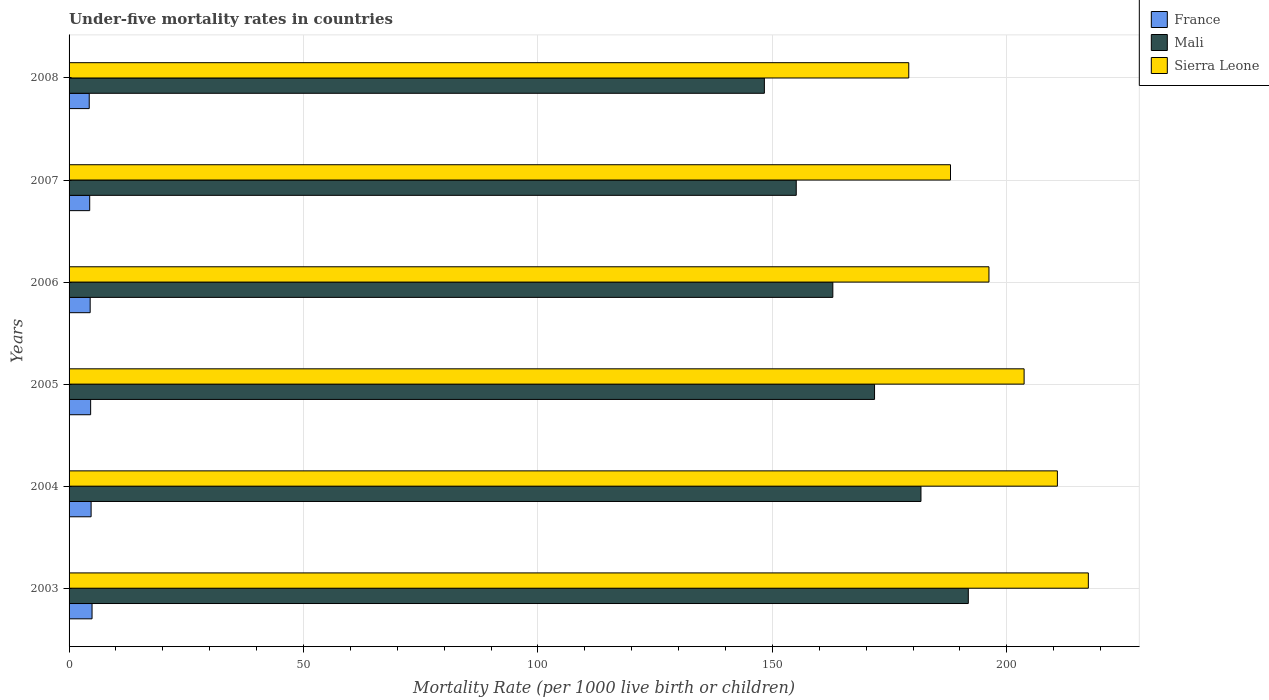How many different coloured bars are there?
Offer a terse response. 3. How many groups of bars are there?
Offer a terse response. 6. Are the number of bars per tick equal to the number of legend labels?
Your answer should be compact. Yes. Are the number of bars on each tick of the Y-axis equal?
Ensure brevity in your answer.  Yes. How many bars are there on the 4th tick from the bottom?
Offer a very short reply. 3. What is the label of the 6th group of bars from the top?
Provide a succinct answer. 2003. Across all years, what is the maximum under-five mortality rate in France?
Offer a terse response. 4.9. Across all years, what is the minimum under-five mortality rate in Sierra Leone?
Your response must be concise. 179.1. In which year was the under-five mortality rate in Sierra Leone maximum?
Your answer should be very brief. 2003. In which year was the under-five mortality rate in France minimum?
Provide a succinct answer. 2008. What is the total under-five mortality rate in Sierra Leone in the graph?
Ensure brevity in your answer.  1195.2. What is the difference between the under-five mortality rate in France in 2006 and that in 2008?
Your answer should be very brief. 0.2. What is the difference between the under-five mortality rate in Mali in 2008 and the under-five mortality rate in France in 2003?
Keep it short and to the point. 143.4. What is the average under-five mortality rate in Mali per year?
Your response must be concise. 168.6. In the year 2007, what is the difference between the under-five mortality rate in Sierra Leone and under-five mortality rate in France?
Ensure brevity in your answer.  183.6. In how many years, is the under-five mortality rate in France greater than 80 ?
Your answer should be compact. 0. What is the ratio of the under-five mortality rate in Mali in 2003 to that in 2005?
Your answer should be very brief. 1.12. Is the under-five mortality rate in Mali in 2004 less than that in 2008?
Your answer should be very brief. No. Is the difference between the under-five mortality rate in Sierra Leone in 2004 and 2007 greater than the difference between the under-five mortality rate in France in 2004 and 2007?
Your response must be concise. Yes. What is the difference between the highest and the second highest under-five mortality rate in France?
Keep it short and to the point. 0.2. What is the difference between the highest and the lowest under-five mortality rate in France?
Make the answer very short. 0.6. Is the sum of the under-five mortality rate in France in 2003 and 2005 greater than the maximum under-five mortality rate in Sierra Leone across all years?
Ensure brevity in your answer.  No. What does the 2nd bar from the top in 2003 represents?
Provide a succinct answer. Mali. What does the 2nd bar from the bottom in 2004 represents?
Keep it short and to the point. Mali. How many bars are there?
Keep it short and to the point. 18. How many years are there in the graph?
Offer a terse response. 6. What is the difference between two consecutive major ticks on the X-axis?
Keep it short and to the point. 50. Are the values on the major ticks of X-axis written in scientific E-notation?
Offer a terse response. No. How are the legend labels stacked?
Make the answer very short. Vertical. What is the title of the graph?
Ensure brevity in your answer.  Under-five mortality rates in countries. Does "Luxembourg" appear as one of the legend labels in the graph?
Give a very brief answer. No. What is the label or title of the X-axis?
Ensure brevity in your answer.  Mortality Rate (per 1000 live birth or children). What is the label or title of the Y-axis?
Offer a terse response. Years. What is the Mortality Rate (per 1000 live birth or children) of Mali in 2003?
Provide a short and direct response. 191.8. What is the Mortality Rate (per 1000 live birth or children) in Sierra Leone in 2003?
Provide a short and direct response. 217.4. What is the Mortality Rate (per 1000 live birth or children) of France in 2004?
Provide a succinct answer. 4.7. What is the Mortality Rate (per 1000 live birth or children) in Mali in 2004?
Provide a succinct answer. 181.7. What is the Mortality Rate (per 1000 live birth or children) of Sierra Leone in 2004?
Offer a terse response. 210.8. What is the Mortality Rate (per 1000 live birth or children) in Mali in 2005?
Your answer should be compact. 171.8. What is the Mortality Rate (per 1000 live birth or children) of Sierra Leone in 2005?
Your answer should be compact. 203.7. What is the Mortality Rate (per 1000 live birth or children) in France in 2006?
Your answer should be very brief. 4.5. What is the Mortality Rate (per 1000 live birth or children) in Mali in 2006?
Ensure brevity in your answer.  162.9. What is the Mortality Rate (per 1000 live birth or children) in Sierra Leone in 2006?
Offer a terse response. 196.2. What is the Mortality Rate (per 1000 live birth or children) in France in 2007?
Provide a short and direct response. 4.4. What is the Mortality Rate (per 1000 live birth or children) in Mali in 2007?
Make the answer very short. 155.1. What is the Mortality Rate (per 1000 live birth or children) of Sierra Leone in 2007?
Provide a succinct answer. 188. What is the Mortality Rate (per 1000 live birth or children) in Mali in 2008?
Your response must be concise. 148.3. What is the Mortality Rate (per 1000 live birth or children) in Sierra Leone in 2008?
Ensure brevity in your answer.  179.1. Across all years, what is the maximum Mortality Rate (per 1000 live birth or children) in France?
Give a very brief answer. 4.9. Across all years, what is the maximum Mortality Rate (per 1000 live birth or children) in Mali?
Your answer should be very brief. 191.8. Across all years, what is the maximum Mortality Rate (per 1000 live birth or children) in Sierra Leone?
Give a very brief answer. 217.4. Across all years, what is the minimum Mortality Rate (per 1000 live birth or children) in Mali?
Offer a terse response. 148.3. Across all years, what is the minimum Mortality Rate (per 1000 live birth or children) of Sierra Leone?
Make the answer very short. 179.1. What is the total Mortality Rate (per 1000 live birth or children) of France in the graph?
Provide a short and direct response. 27.4. What is the total Mortality Rate (per 1000 live birth or children) of Mali in the graph?
Provide a short and direct response. 1011.6. What is the total Mortality Rate (per 1000 live birth or children) of Sierra Leone in the graph?
Provide a succinct answer. 1195.2. What is the difference between the Mortality Rate (per 1000 live birth or children) of France in 2003 and that in 2004?
Keep it short and to the point. 0.2. What is the difference between the Mortality Rate (per 1000 live birth or children) in Mali in 2003 and that in 2004?
Offer a terse response. 10.1. What is the difference between the Mortality Rate (per 1000 live birth or children) in Sierra Leone in 2003 and that in 2004?
Your answer should be compact. 6.6. What is the difference between the Mortality Rate (per 1000 live birth or children) of Mali in 2003 and that in 2005?
Your response must be concise. 20. What is the difference between the Mortality Rate (per 1000 live birth or children) in Sierra Leone in 2003 and that in 2005?
Ensure brevity in your answer.  13.7. What is the difference between the Mortality Rate (per 1000 live birth or children) of Mali in 2003 and that in 2006?
Your response must be concise. 28.9. What is the difference between the Mortality Rate (per 1000 live birth or children) in Sierra Leone in 2003 and that in 2006?
Offer a very short reply. 21.2. What is the difference between the Mortality Rate (per 1000 live birth or children) of Mali in 2003 and that in 2007?
Offer a very short reply. 36.7. What is the difference between the Mortality Rate (per 1000 live birth or children) in Sierra Leone in 2003 and that in 2007?
Provide a succinct answer. 29.4. What is the difference between the Mortality Rate (per 1000 live birth or children) in Mali in 2003 and that in 2008?
Provide a succinct answer. 43.5. What is the difference between the Mortality Rate (per 1000 live birth or children) of Sierra Leone in 2003 and that in 2008?
Keep it short and to the point. 38.3. What is the difference between the Mortality Rate (per 1000 live birth or children) of France in 2004 and that in 2005?
Offer a very short reply. 0.1. What is the difference between the Mortality Rate (per 1000 live birth or children) of Sierra Leone in 2004 and that in 2005?
Give a very brief answer. 7.1. What is the difference between the Mortality Rate (per 1000 live birth or children) of France in 2004 and that in 2006?
Offer a very short reply. 0.2. What is the difference between the Mortality Rate (per 1000 live birth or children) in Mali in 2004 and that in 2006?
Your answer should be very brief. 18.8. What is the difference between the Mortality Rate (per 1000 live birth or children) of Mali in 2004 and that in 2007?
Your answer should be compact. 26.6. What is the difference between the Mortality Rate (per 1000 live birth or children) in Sierra Leone in 2004 and that in 2007?
Your answer should be very brief. 22.8. What is the difference between the Mortality Rate (per 1000 live birth or children) of Mali in 2004 and that in 2008?
Give a very brief answer. 33.4. What is the difference between the Mortality Rate (per 1000 live birth or children) of Sierra Leone in 2004 and that in 2008?
Make the answer very short. 31.7. What is the difference between the Mortality Rate (per 1000 live birth or children) in France in 2005 and that in 2006?
Provide a succinct answer. 0.1. What is the difference between the Mortality Rate (per 1000 live birth or children) of Mali in 2005 and that in 2006?
Your answer should be very brief. 8.9. What is the difference between the Mortality Rate (per 1000 live birth or children) of Sierra Leone in 2005 and that in 2006?
Provide a short and direct response. 7.5. What is the difference between the Mortality Rate (per 1000 live birth or children) in Mali in 2005 and that in 2007?
Your answer should be very brief. 16.7. What is the difference between the Mortality Rate (per 1000 live birth or children) of Sierra Leone in 2005 and that in 2007?
Offer a terse response. 15.7. What is the difference between the Mortality Rate (per 1000 live birth or children) of Mali in 2005 and that in 2008?
Provide a succinct answer. 23.5. What is the difference between the Mortality Rate (per 1000 live birth or children) in Sierra Leone in 2005 and that in 2008?
Your response must be concise. 24.6. What is the difference between the Mortality Rate (per 1000 live birth or children) of Mali in 2006 and that in 2007?
Make the answer very short. 7.8. What is the difference between the Mortality Rate (per 1000 live birth or children) of Mali in 2006 and that in 2008?
Your answer should be compact. 14.6. What is the difference between the Mortality Rate (per 1000 live birth or children) in Sierra Leone in 2006 and that in 2008?
Offer a very short reply. 17.1. What is the difference between the Mortality Rate (per 1000 live birth or children) of Mali in 2007 and that in 2008?
Provide a succinct answer. 6.8. What is the difference between the Mortality Rate (per 1000 live birth or children) in Sierra Leone in 2007 and that in 2008?
Your answer should be compact. 8.9. What is the difference between the Mortality Rate (per 1000 live birth or children) of France in 2003 and the Mortality Rate (per 1000 live birth or children) of Mali in 2004?
Give a very brief answer. -176.8. What is the difference between the Mortality Rate (per 1000 live birth or children) of France in 2003 and the Mortality Rate (per 1000 live birth or children) of Sierra Leone in 2004?
Provide a short and direct response. -205.9. What is the difference between the Mortality Rate (per 1000 live birth or children) of Mali in 2003 and the Mortality Rate (per 1000 live birth or children) of Sierra Leone in 2004?
Keep it short and to the point. -19. What is the difference between the Mortality Rate (per 1000 live birth or children) of France in 2003 and the Mortality Rate (per 1000 live birth or children) of Mali in 2005?
Offer a terse response. -166.9. What is the difference between the Mortality Rate (per 1000 live birth or children) of France in 2003 and the Mortality Rate (per 1000 live birth or children) of Sierra Leone in 2005?
Offer a terse response. -198.8. What is the difference between the Mortality Rate (per 1000 live birth or children) of France in 2003 and the Mortality Rate (per 1000 live birth or children) of Mali in 2006?
Provide a short and direct response. -158. What is the difference between the Mortality Rate (per 1000 live birth or children) of France in 2003 and the Mortality Rate (per 1000 live birth or children) of Sierra Leone in 2006?
Your answer should be very brief. -191.3. What is the difference between the Mortality Rate (per 1000 live birth or children) in Mali in 2003 and the Mortality Rate (per 1000 live birth or children) in Sierra Leone in 2006?
Provide a succinct answer. -4.4. What is the difference between the Mortality Rate (per 1000 live birth or children) of France in 2003 and the Mortality Rate (per 1000 live birth or children) of Mali in 2007?
Provide a short and direct response. -150.2. What is the difference between the Mortality Rate (per 1000 live birth or children) of France in 2003 and the Mortality Rate (per 1000 live birth or children) of Sierra Leone in 2007?
Offer a terse response. -183.1. What is the difference between the Mortality Rate (per 1000 live birth or children) of Mali in 2003 and the Mortality Rate (per 1000 live birth or children) of Sierra Leone in 2007?
Your response must be concise. 3.8. What is the difference between the Mortality Rate (per 1000 live birth or children) of France in 2003 and the Mortality Rate (per 1000 live birth or children) of Mali in 2008?
Give a very brief answer. -143.4. What is the difference between the Mortality Rate (per 1000 live birth or children) of France in 2003 and the Mortality Rate (per 1000 live birth or children) of Sierra Leone in 2008?
Provide a succinct answer. -174.2. What is the difference between the Mortality Rate (per 1000 live birth or children) in France in 2004 and the Mortality Rate (per 1000 live birth or children) in Mali in 2005?
Your answer should be compact. -167.1. What is the difference between the Mortality Rate (per 1000 live birth or children) of France in 2004 and the Mortality Rate (per 1000 live birth or children) of Sierra Leone in 2005?
Provide a short and direct response. -199. What is the difference between the Mortality Rate (per 1000 live birth or children) of France in 2004 and the Mortality Rate (per 1000 live birth or children) of Mali in 2006?
Your answer should be very brief. -158.2. What is the difference between the Mortality Rate (per 1000 live birth or children) of France in 2004 and the Mortality Rate (per 1000 live birth or children) of Sierra Leone in 2006?
Your answer should be compact. -191.5. What is the difference between the Mortality Rate (per 1000 live birth or children) in Mali in 2004 and the Mortality Rate (per 1000 live birth or children) in Sierra Leone in 2006?
Provide a short and direct response. -14.5. What is the difference between the Mortality Rate (per 1000 live birth or children) of France in 2004 and the Mortality Rate (per 1000 live birth or children) of Mali in 2007?
Offer a very short reply. -150.4. What is the difference between the Mortality Rate (per 1000 live birth or children) in France in 2004 and the Mortality Rate (per 1000 live birth or children) in Sierra Leone in 2007?
Offer a very short reply. -183.3. What is the difference between the Mortality Rate (per 1000 live birth or children) of Mali in 2004 and the Mortality Rate (per 1000 live birth or children) of Sierra Leone in 2007?
Keep it short and to the point. -6.3. What is the difference between the Mortality Rate (per 1000 live birth or children) of France in 2004 and the Mortality Rate (per 1000 live birth or children) of Mali in 2008?
Provide a short and direct response. -143.6. What is the difference between the Mortality Rate (per 1000 live birth or children) in France in 2004 and the Mortality Rate (per 1000 live birth or children) in Sierra Leone in 2008?
Offer a very short reply. -174.4. What is the difference between the Mortality Rate (per 1000 live birth or children) in Mali in 2004 and the Mortality Rate (per 1000 live birth or children) in Sierra Leone in 2008?
Offer a very short reply. 2.6. What is the difference between the Mortality Rate (per 1000 live birth or children) in France in 2005 and the Mortality Rate (per 1000 live birth or children) in Mali in 2006?
Your answer should be compact. -158.3. What is the difference between the Mortality Rate (per 1000 live birth or children) in France in 2005 and the Mortality Rate (per 1000 live birth or children) in Sierra Leone in 2006?
Your response must be concise. -191.6. What is the difference between the Mortality Rate (per 1000 live birth or children) of Mali in 2005 and the Mortality Rate (per 1000 live birth or children) of Sierra Leone in 2006?
Provide a short and direct response. -24.4. What is the difference between the Mortality Rate (per 1000 live birth or children) in France in 2005 and the Mortality Rate (per 1000 live birth or children) in Mali in 2007?
Give a very brief answer. -150.5. What is the difference between the Mortality Rate (per 1000 live birth or children) in France in 2005 and the Mortality Rate (per 1000 live birth or children) in Sierra Leone in 2007?
Your answer should be very brief. -183.4. What is the difference between the Mortality Rate (per 1000 live birth or children) in Mali in 2005 and the Mortality Rate (per 1000 live birth or children) in Sierra Leone in 2007?
Your answer should be very brief. -16.2. What is the difference between the Mortality Rate (per 1000 live birth or children) in France in 2005 and the Mortality Rate (per 1000 live birth or children) in Mali in 2008?
Keep it short and to the point. -143.7. What is the difference between the Mortality Rate (per 1000 live birth or children) of France in 2005 and the Mortality Rate (per 1000 live birth or children) of Sierra Leone in 2008?
Your response must be concise. -174.5. What is the difference between the Mortality Rate (per 1000 live birth or children) in Mali in 2005 and the Mortality Rate (per 1000 live birth or children) in Sierra Leone in 2008?
Offer a terse response. -7.3. What is the difference between the Mortality Rate (per 1000 live birth or children) in France in 2006 and the Mortality Rate (per 1000 live birth or children) in Mali in 2007?
Your answer should be very brief. -150.6. What is the difference between the Mortality Rate (per 1000 live birth or children) in France in 2006 and the Mortality Rate (per 1000 live birth or children) in Sierra Leone in 2007?
Provide a short and direct response. -183.5. What is the difference between the Mortality Rate (per 1000 live birth or children) of Mali in 2006 and the Mortality Rate (per 1000 live birth or children) of Sierra Leone in 2007?
Your answer should be very brief. -25.1. What is the difference between the Mortality Rate (per 1000 live birth or children) in France in 2006 and the Mortality Rate (per 1000 live birth or children) in Mali in 2008?
Your answer should be very brief. -143.8. What is the difference between the Mortality Rate (per 1000 live birth or children) of France in 2006 and the Mortality Rate (per 1000 live birth or children) of Sierra Leone in 2008?
Offer a terse response. -174.6. What is the difference between the Mortality Rate (per 1000 live birth or children) in Mali in 2006 and the Mortality Rate (per 1000 live birth or children) in Sierra Leone in 2008?
Offer a very short reply. -16.2. What is the difference between the Mortality Rate (per 1000 live birth or children) of France in 2007 and the Mortality Rate (per 1000 live birth or children) of Mali in 2008?
Give a very brief answer. -143.9. What is the difference between the Mortality Rate (per 1000 live birth or children) in France in 2007 and the Mortality Rate (per 1000 live birth or children) in Sierra Leone in 2008?
Keep it short and to the point. -174.7. What is the difference between the Mortality Rate (per 1000 live birth or children) of Mali in 2007 and the Mortality Rate (per 1000 live birth or children) of Sierra Leone in 2008?
Keep it short and to the point. -24. What is the average Mortality Rate (per 1000 live birth or children) in France per year?
Your answer should be very brief. 4.57. What is the average Mortality Rate (per 1000 live birth or children) in Mali per year?
Your answer should be compact. 168.6. What is the average Mortality Rate (per 1000 live birth or children) in Sierra Leone per year?
Offer a terse response. 199.2. In the year 2003, what is the difference between the Mortality Rate (per 1000 live birth or children) in France and Mortality Rate (per 1000 live birth or children) in Mali?
Your answer should be compact. -186.9. In the year 2003, what is the difference between the Mortality Rate (per 1000 live birth or children) of France and Mortality Rate (per 1000 live birth or children) of Sierra Leone?
Offer a terse response. -212.5. In the year 2003, what is the difference between the Mortality Rate (per 1000 live birth or children) in Mali and Mortality Rate (per 1000 live birth or children) in Sierra Leone?
Keep it short and to the point. -25.6. In the year 2004, what is the difference between the Mortality Rate (per 1000 live birth or children) in France and Mortality Rate (per 1000 live birth or children) in Mali?
Your answer should be very brief. -177. In the year 2004, what is the difference between the Mortality Rate (per 1000 live birth or children) in France and Mortality Rate (per 1000 live birth or children) in Sierra Leone?
Provide a short and direct response. -206.1. In the year 2004, what is the difference between the Mortality Rate (per 1000 live birth or children) of Mali and Mortality Rate (per 1000 live birth or children) of Sierra Leone?
Offer a very short reply. -29.1. In the year 2005, what is the difference between the Mortality Rate (per 1000 live birth or children) in France and Mortality Rate (per 1000 live birth or children) in Mali?
Provide a short and direct response. -167.2. In the year 2005, what is the difference between the Mortality Rate (per 1000 live birth or children) of France and Mortality Rate (per 1000 live birth or children) of Sierra Leone?
Ensure brevity in your answer.  -199.1. In the year 2005, what is the difference between the Mortality Rate (per 1000 live birth or children) of Mali and Mortality Rate (per 1000 live birth or children) of Sierra Leone?
Provide a short and direct response. -31.9. In the year 2006, what is the difference between the Mortality Rate (per 1000 live birth or children) of France and Mortality Rate (per 1000 live birth or children) of Mali?
Provide a short and direct response. -158.4. In the year 2006, what is the difference between the Mortality Rate (per 1000 live birth or children) of France and Mortality Rate (per 1000 live birth or children) of Sierra Leone?
Your answer should be compact. -191.7. In the year 2006, what is the difference between the Mortality Rate (per 1000 live birth or children) of Mali and Mortality Rate (per 1000 live birth or children) of Sierra Leone?
Your answer should be very brief. -33.3. In the year 2007, what is the difference between the Mortality Rate (per 1000 live birth or children) in France and Mortality Rate (per 1000 live birth or children) in Mali?
Make the answer very short. -150.7. In the year 2007, what is the difference between the Mortality Rate (per 1000 live birth or children) of France and Mortality Rate (per 1000 live birth or children) of Sierra Leone?
Provide a short and direct response. -183.6. In the year 2007, what is the difference between the Mortality Rate (per 1000 live birth or children) of Mali and Mortality Rate (per 1000 live birth or children) of Sierra Leone?
Your response must be concise. -32.9. In the year 2008, what is the difference between the Mortality Rate (per 1000 live birth or children) in France and Mortality Rate (per 1000 live birth or children) in Mali?
Your answer should be very brief. -144. In the year 2008, what is the difference between the Mortality Rate (per 1000 live birth or children) in France and Mortality Rate (per 1000 live birth or children) in Sierra Leone?
Ensure brevity in your answer.  -174.8. In the year 2008, what is the difference between the Mortality Rate (per 1000 live birth or children) in Mali and Mortality Rate (per 1000 live birth or children) in Sierra Leone?
Give a very brief answer. -30.8. What is the ratio of the Mortality Rate (per 1000 live birth or children) of France in 2003 to that in 2004?
Keep it short and to the point. 1.04. What is the ratio of the Mortality Rate (per 1000 live birth or children) in Mali in 2003 to that in 2004?
Your response must be concise. 1.06. What is the ratio of the Mortality Rate (per 1000 live birth or children) in Sierra Leone in 2003 to that in 2004?
Provide a succinct answer. 1.03. What is the ratio of the Mortality Rate (per 1000 live birth or children) of France in 2003 to that in 2005?
Keep it short and to the point. 1.07. What is the ratio of the Mortality Rate (per 1000 live birth or children) of Mali in 2003 to that in 2005?
Ensure brevity in your answer.  1.12. What is the ratio of the Mortality Rate (per 1000 live birth or children) of Sierra Leone in 2003 to that in 2005?
Offer a very short reply. 1.07. What is the ratio of the Mortality Rate (per 1000 live birth or children) of France in 2003 to that in 2006?
Your answer should be compact. 1.09. What is the ratio of the Mortality Rate (per 1000 live birth or children) in Mali in 2003 to that in 2006?
Offer a very short reply. 1.18. What is the ratio of the Mortality Rate (per 1000 live birth or children) in Sierra Leone in 2003 to that in 2006?
Your response must be concise. 1.11. What is the ratio of the Mortality Rate (per 1000 live birth or children) in France in 2003 to that in 2007?
Your answer should be very brief. 1.11. What is the ratio of the Mortality Rate (per 1000 live birth or children) in Mali in 2003 to that in 2007?
Your answer should be very brief. 1.24. What is the ratio of the Mortality Rate (per 1000 live birth or children) in Sierra Leone in 2003 to that in 2007?
Your answer should be very brief. 1.16. What is the ratio of the Mortality Rate (per 1000 live birth or children) in France in 2003 to that in 2008?
Your answer should be very brief. 1.14. What is the ratio of the Mortality Rate (per 1000 live birth or children) of Mali in 2003 to that in 2008?
Provide a short and direct response. 1.29. What is the ratio of the Mortality Rate (per 1000 live birth or children) of Sierra Leone in 2003 to that in 2008?
Your answer should be very brief. 1.21. What is the ratio of the Mortality Rate (per 1000 live birth or children) in France in 2004 to that in 2005?
Your response must be concise. 1.02. What is the ratio of the Mortality Rate (per 1000 live birth or children) of Mali in 2004 to that in 2005?
Offer a terse response. 1.06. What is the ratio of the Mortality Rate (per 1000 live birth or children) of Sierra Leone in 2004 to that in 2005?
Ensure brevity in your answer.  1.03. What is the ratio of the Mortality Rate (per 1000 live birth or children) in France in 2004 to that in 2006?
Provide a short and direct response. 1.04. What is the ratio of the Mortality Rate (per 1000 live birth or children) in Mali in 2004 to that in 2006?
Your response must be concise. 1.12. What is the ratio of the Mortality Rate (per 1000 live birth or children) of Sierra Leone in 2004 to that in 2006?
Give a very brief answer. 1.07. What is the ratio of the Mortality Rate (per 1000 live birth or children) of France in 2004 to that in 2007?
Offer a terse response. 1.07. What is the ratio of the Mortality Rate (per 1000 live birth or children) of Mali in 2004 to that in 2007?
Offer a very short reply. 1.17. What is the ratio of the Mortality Rate (per 1000 live birth or children) of Sierra Leone in 2004 to that in 2007?
Your response must be concise. 1.12. What is the ratio of the Mortality Rate (per 1000 live birth or children) in France in 2004 to that in 2008?
Your answer should be compact. 1.09. What is the ratio of the Mortality Rate (per 1000 live birth or children) of Mali in 2004 to that in 2008?
Keep it short and to the point. 1.23. What is the ratio of the Mortality Rate (per 1000 live birth or children) of Sierra Leone in 2004 to that in 2008?
Your answer should be compact. 1.18. What is the ratio of the Mortality Rate (per 1000 live birth or children) in France in 2005 to that in 2006?
Ensure brevity in your answer.  1.02. What is the ratio of the Mortality Rate (per 1000 live birth or children) in Mali in 2005 to that in 2006?
Provide a short and direct response. 1.05. What is the ratio of the Mortality Rate (per 1000 live birth or children) of Sierra Leone in 2005 to that in 2006?
Give a very brief answer. 1.04. What is the ratio of the Mortality Rate (per 1000 live birth or children) of France in 2005 to that in 2007?
Your response must be concise. 1.05. What is the ratio of the Mortality Rate (per 1000 live birth or children) of Mali in 2005 to that in 2007?
Keep it short and to the point. 1.11. What is the ratio of the Mortality Rate (per 1000 live birth or children) in Sierra Leone in 2005 to that in 2007?
Keep it short and to the point. 1.08. What is the ratio of the Mortality Rate (per 1000 live birth or children) in France in 2005 to that in 2008?
Ensure brevity in your answer.  1.07. What is the ratio of the Mortality Rate (per 1000 live birth or children) of Mali in 2005 to that in 2008?
Offer a very short reply. 1.16. What is the ratio of the Mortality Rate (per 1000 live birth or children) of Sierra Leone in 2005 to that in 2008?
Keep it short and to the point. 1.14. What is the ratio of the Mortality Rate (per 1000 live birth or children) of France in 2006 to that in 2007?
Offer a terse response. 1.02. What is the ratio of the Mortality Rate (per 1000 live birth or children) of Mali in 2006 to that in 2007?
Your response must be concise. 1.05. What is the ratio of the Mortality Rate (per 1000 live birth or children) of Sierra Leone in 2006 to that in 2007?
Ensure brevity in your answer.  1.04. What is the ratio of the Mortality Rate (per 1000 live birth or children) of France in 2006 to that in 2008?
Your answer should be very brief. 1.05. What is the ratio of the Mortality Rate (per 1000 live birth or children) in Mali in 2006 to that in 2008?
Your response must be concise. 1.1. What is the ratio of the Mortality Rate (per 1000 live birth or children) of Sierra Leone in 2006 to that in 2008?
Your answer should be compact. 1.1. What is the ratio of the Mortality Rate (per 1000 live birth or children) of France in 2007 to that in 2008?
Your answer should be compact. 1.02. What is the ratio of the Mortality Rate (per 1000 live birth or children) in Mali in 2007 to that in 2008?
Offer a terse response. 1.05. What is the ratio of the Mortality Rate (per 1000 live birth or children) of Sierra Leone in 2007 to that in 2008?
Ensure brevity in your answer.  1.05. What is the difference between the highest and the second highest Mortality Rate (per 1000 live birth or children) in France?
Ensure brevity in your answer.  0.2. What is the difference between the highest and the second highest Mortality Rate (per 1000 live birth or children) of Mali?
Keep it short and to the point. 10.1. What is the difference between the highest and the second highest Mortality Rate (per 1000 live birth or children) in Sierra Leone?
Your answer should be very brief. 6.6. What is the difference between the highest and the lowest Mortality Rate (per 1000 live birth or children) of Mali?
Ensure brevity in your answer.  43.5. What is the difference between the highest and the lowest Mortality Rate (per 1000 live birth or children) of Sierra Leone?
Give a very brief answer. 38.3. 